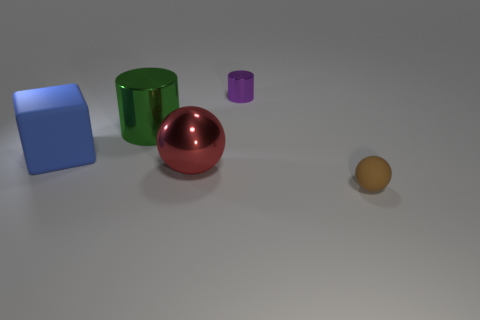Add 3 large green objects. How many objects exist? 8 Subtract all spheres. How many objects are left? 3 Subtract all tiny metallic cylinders. Subtract all tiny purple metal cylinders. How many objects are left? 3 Add 3 brown things. How many brown things are left? 4 Add 4 tiny shiny objects. How many tiny shiny objects exist? 5 Subtract 0 purple balls. How many objects are left? 5 